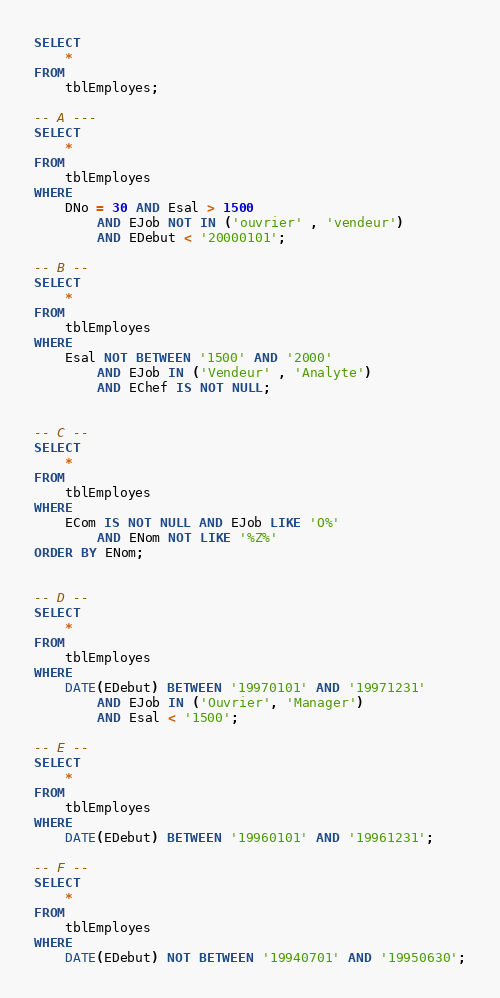Convert code to text. <code><loc_0><loc_0><loc_500><loc_500><_SQL_>SELECT 
    *
FROM
    tblEmployes;
    
-- A ---
SELECT 
    *
FROM
    tblEmployes
WHERE
    DNo = 30 AND Esal > 1500
        AND EJob NOT IN ('ouvrier' , 'vendeur')
        AND EDebut < '20000101';

-- B --
SELECT 
    *
FROM
    tblEmployes
WHERE
    Esal NOT BETWEEN '1500' AND '2000'
        AND EJob IN ('Vendeur' , 'Analyte')
        AND EChef IS NOT NULL;


-- C --
SELECT 
    *
FROM
    tblEmployes
WHERE
    ECom IS NOT NULL AND EJob LIKE 'O%'
        AND ENom NOT LIKE '%Z%'
ORDER BY ENom;


-- D --
SELECT 
    *
FROM
    tblEmployes
WHERE
    DATE(EDebut) BETWEEN '19970101' AND '19971231'
        AND EJob IN ('Ouvrier', 'Manager') 
        AND Esal < '1500';
        
-- E --
SELECT 
    *
FROM
    tblEmployes
WHERE
    DATE(EDebut) BETWEEN '19960101' AND '19961231';

-- F --
SELECT 
    *
FROM
    tblEmployes
WHERE
    DATE(EDebut) NOT BETWEEN '19940701' AND '19950630';

</code> 